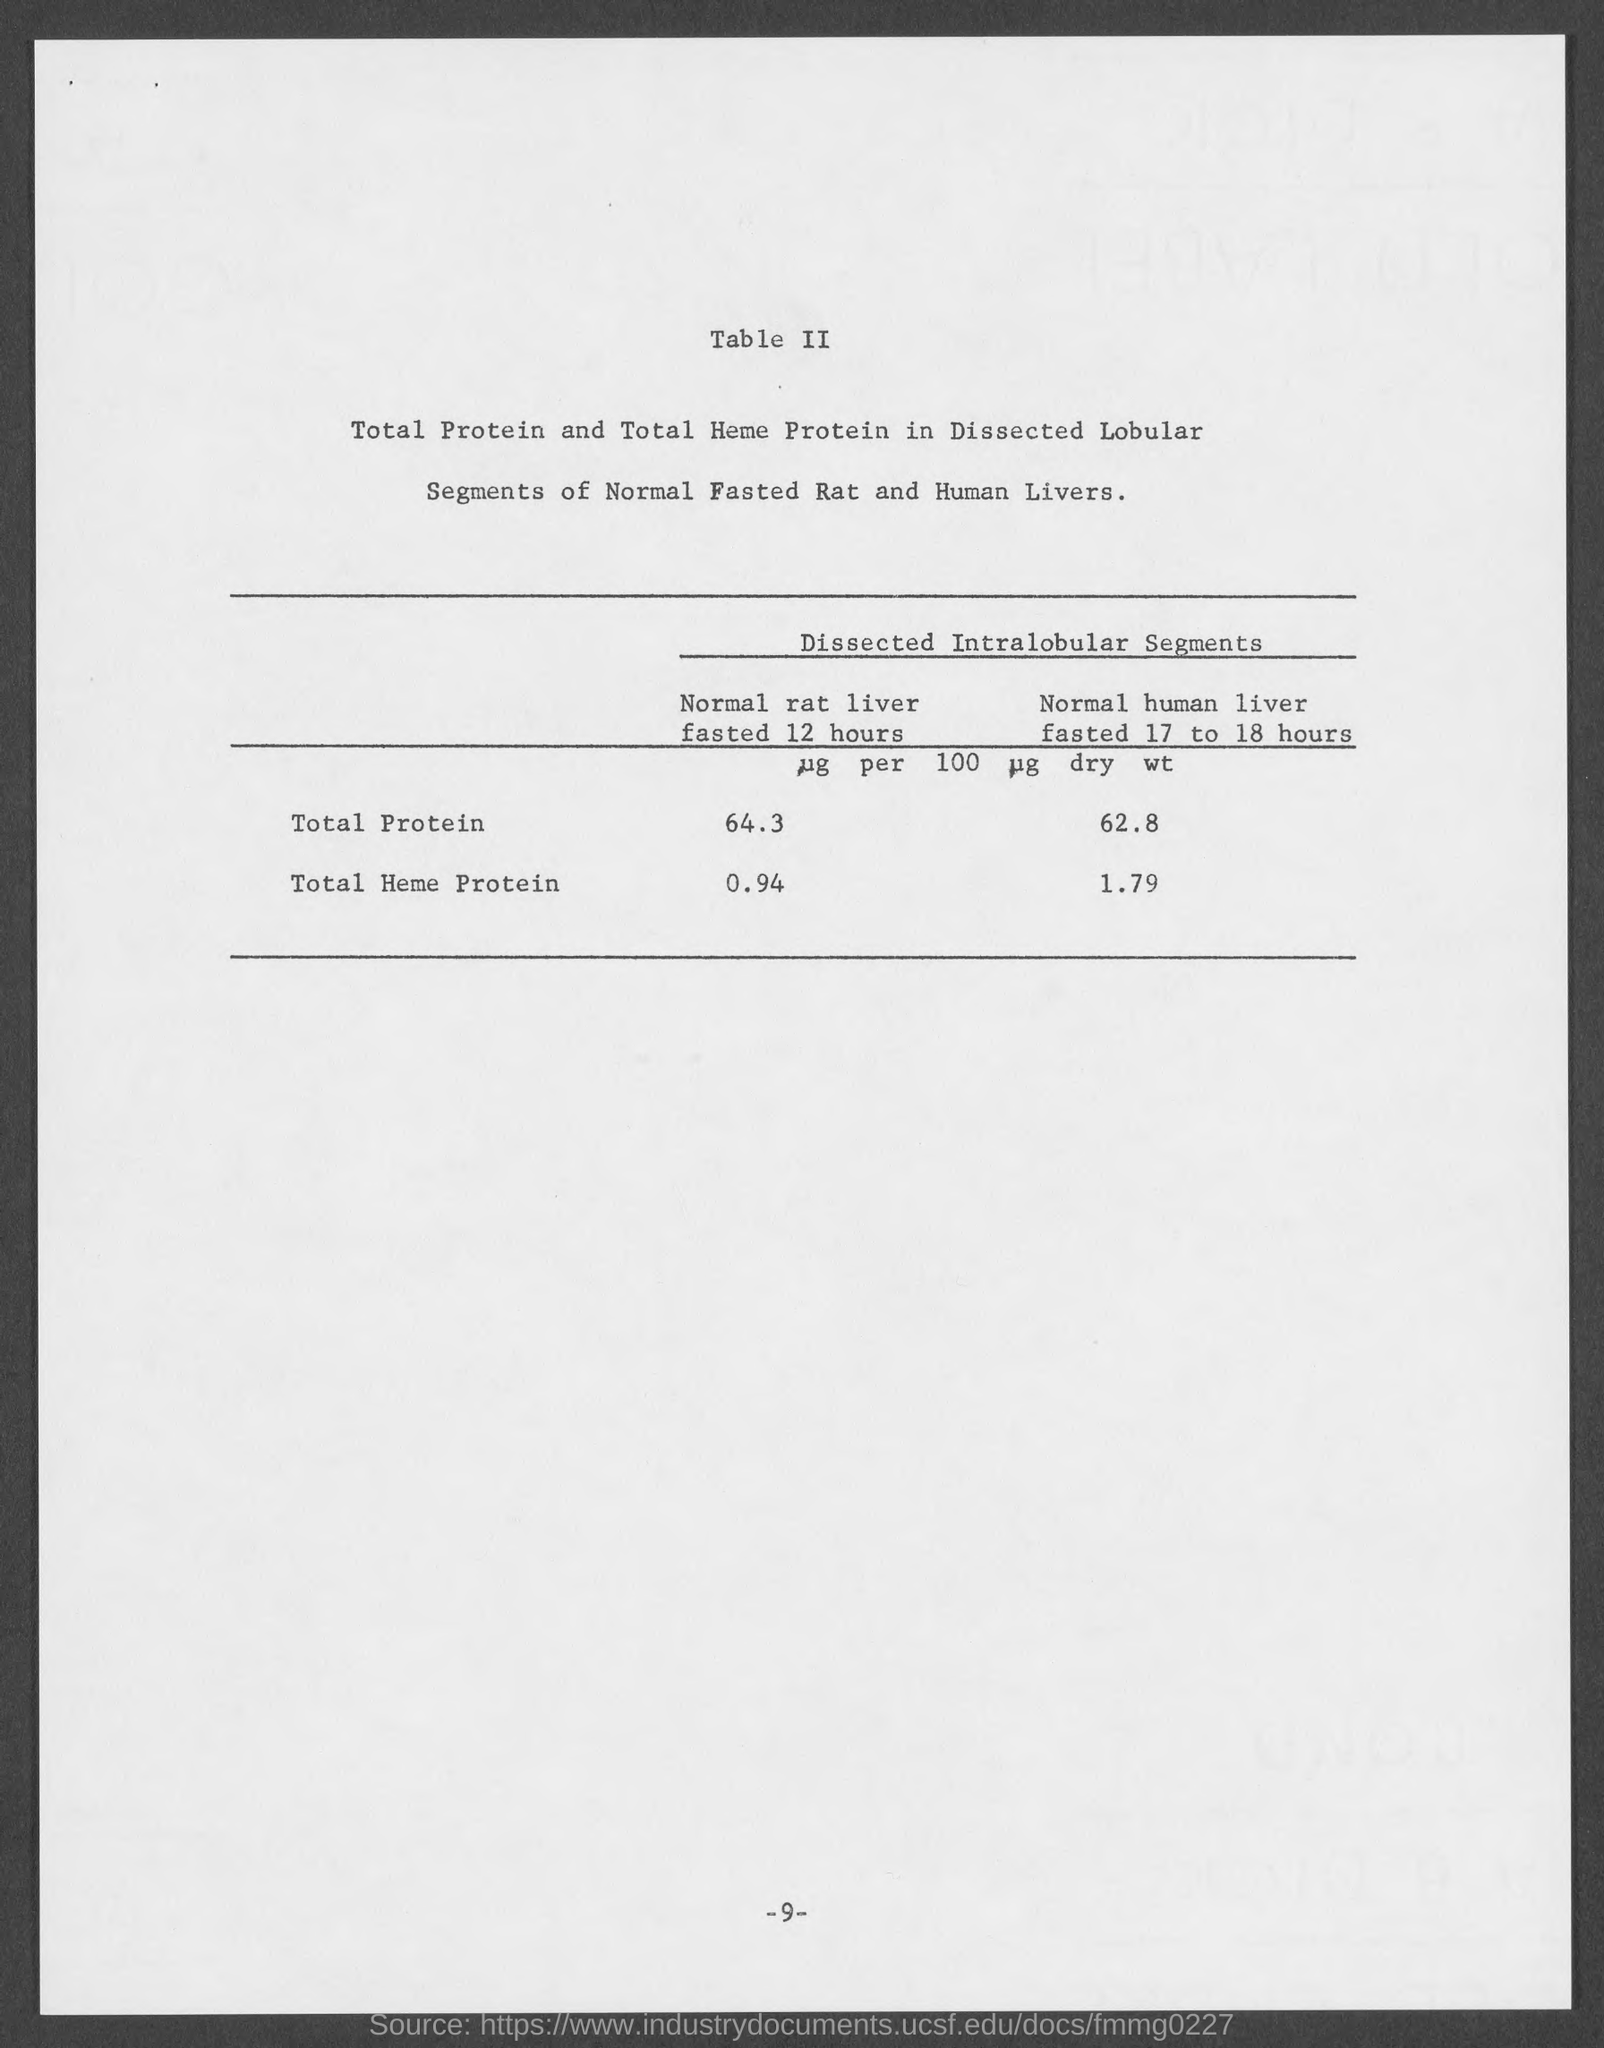How much is the total protein in Normal rat liver fasted 12 hours?
Provide a short and direct response. 64.3. How much is the total heme protein in Normal human liver fasted 17 to 18 hours?
Provide a short and direct response. 1.79. 